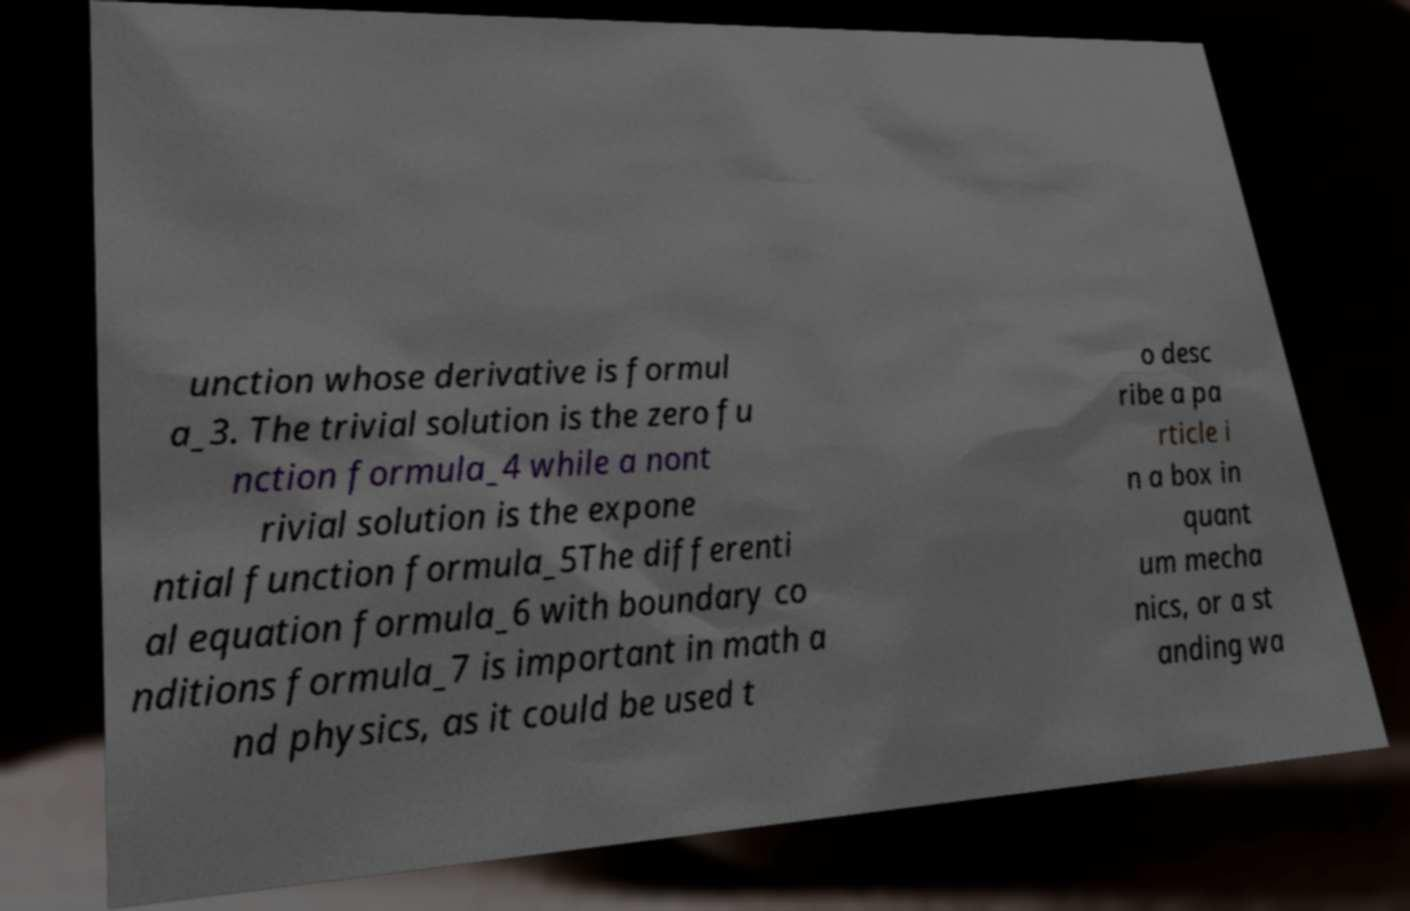What messages or text are displayed in this image? I need them in a readable, typed format. unction whose derivative is formul a_3. The trivial solution is the zero fu nction formula_4 while a nont rivial solution is the expone ntial function formula_5The differenti al equation formula_6 with boundary co nditions formula_7 is important in math a nd physics, as it could be used t o desc ribe a pa rticle i n a box in quant um mecha nics, or a st anding wa 